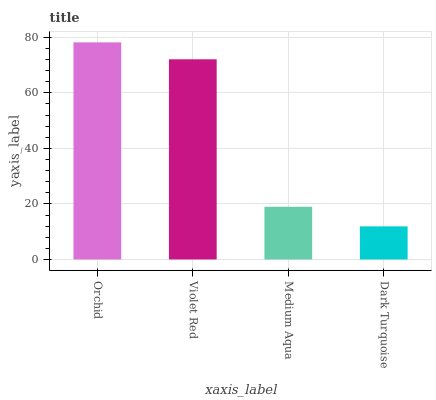Is Dark Turquoise the minimum?
Answer yes or no. Yes. Is Orchid the maximum?
Answer yes or no. Yes. Is Violet Red the minimum?
Answer yes or no. No. Is Violet Red the maximum?
Answer yes or no. No. Is Orchid greater than Violet Red?
Answer yes or no. Yes. Is Violet Red less than Orchid?
Answer yes or no. Yes. Is Violet Red greater than Orchid?
Answer yes or no. No. Is Orchid less than Violet Red?
Answer yes or no. No. Is Violet Red the high median?
Answer yes or no. Yes. Is Medium Aqua the low median?
Answer yes or no. Yes. Is Orchid the high median?
Answer yes or no. No. Is Violet Red the low median?
Answer yes or no. No. 